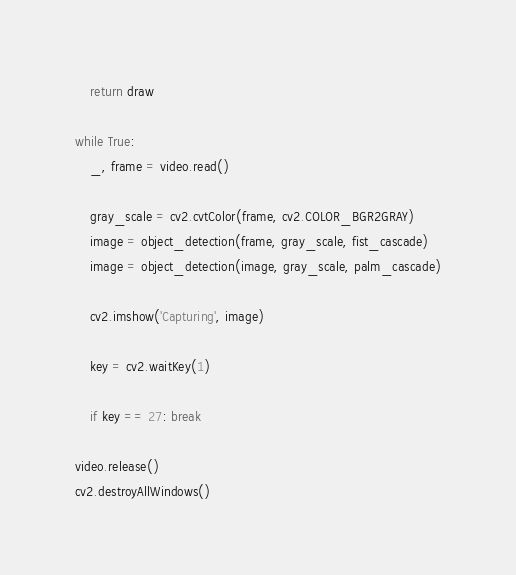<code> <loc_0><loc_0><loc_500><loc_500><_Python_>	return draw

while True:
	_, frame = video.read()

	gray_scale = cv2.cvtColor(frame, cv2.COLOR_BGR2GRAY)
	image = object_detection(frame, gray_scale, fist_cascade)
	image = object_detection(image, gray_scale, palm_cascade)

	cv2.imshow('Capturing', image)

	key = cv2.waitKey(1)

	if key == 27: break

video.release()
cv2.destroyAllWindows()</code> 